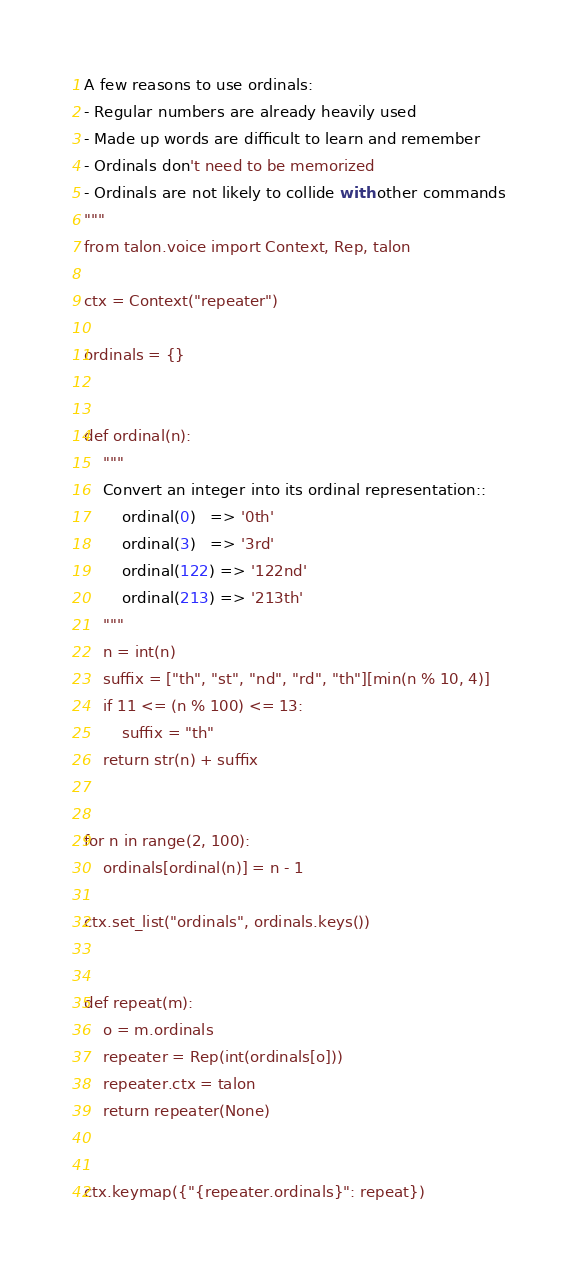Convert code to text. <code><loc_0><loc_0><loc_500><loc_500><_Python_>
A few reasons to use ordinals:
- Regular numbers are already heavily used
- Made up words are difficult to learn and remember
- Ordinals don't need to be memorized
- Ordinals are not likely to collide with other commands
"""
from talon.voice import Context, Rep, talon

ctx = Context("repeater")

ordinals = {}


def ordinal(n):
    """
    Convert an integer into its ordinal representation::
        ordinal(0)   => '0th'
        ordinal(3)   => '3rd'
        ordinal(122) => '122nd'
        ordinal(213) => '213th'
    """
    n = int(n)
    suffix = ["th", "st", "nd", "rd", "th"][min(n % 10, 4)]
    if 11 <= (n % 100) <= 13:
        suffix = "th"
    return str(n) + suffix


for n in range(2, 100):
    ordinals[ordinal(n)] = n - 1

ctx.set_list("ordinals", ordinals.keys())


def repeat(m):
    o = m.ordinals
    repeater = Rep(int(ordinals[o]))
    repeater.ctx = talon
    return repeater(None)


ctx.keymap({"{repeater.ordinals}": repeat})
</code> 